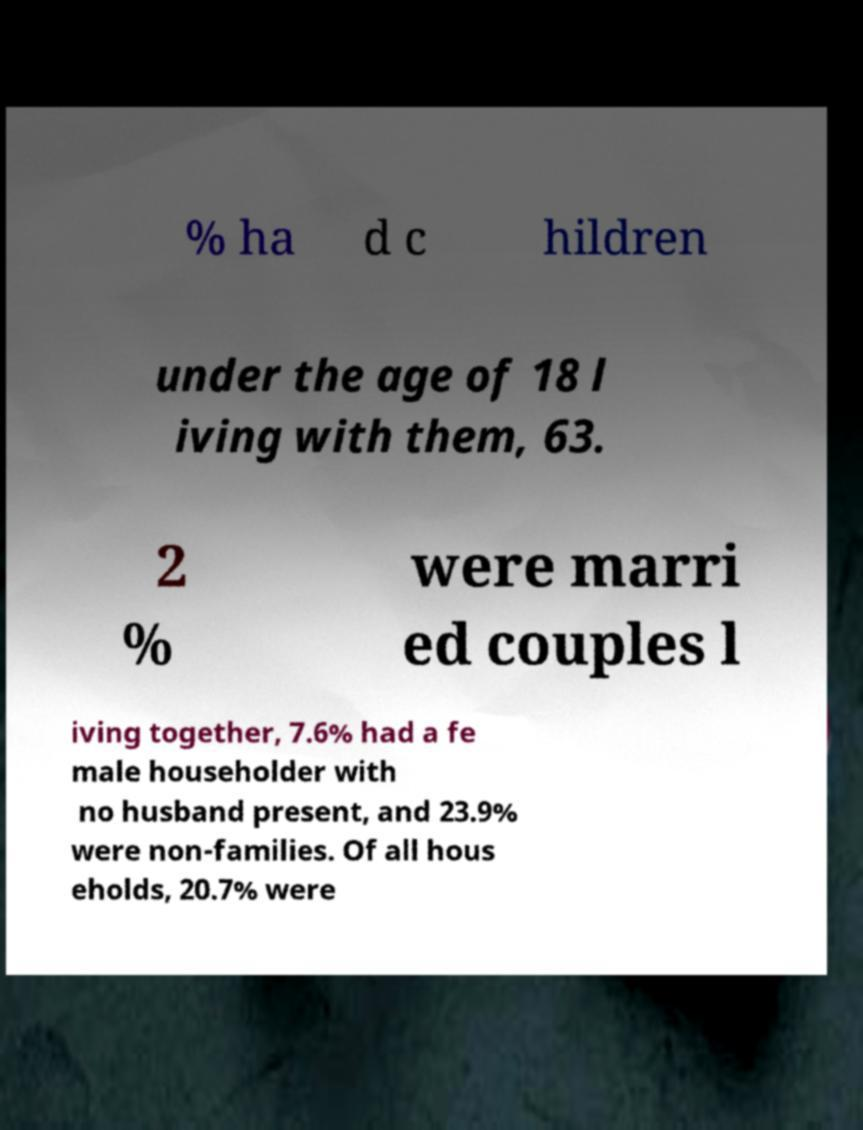For documentation purposes, I need the text within this image transcribed. Could you provide that? % ha d c hildren under the age of 18 l iving with them, 63. 2 % were marri ed couples l iving together, 7.6% had a fe male householder with no husband present, and 23.9% were non-families. Of all hous eholds, 20.7% were 